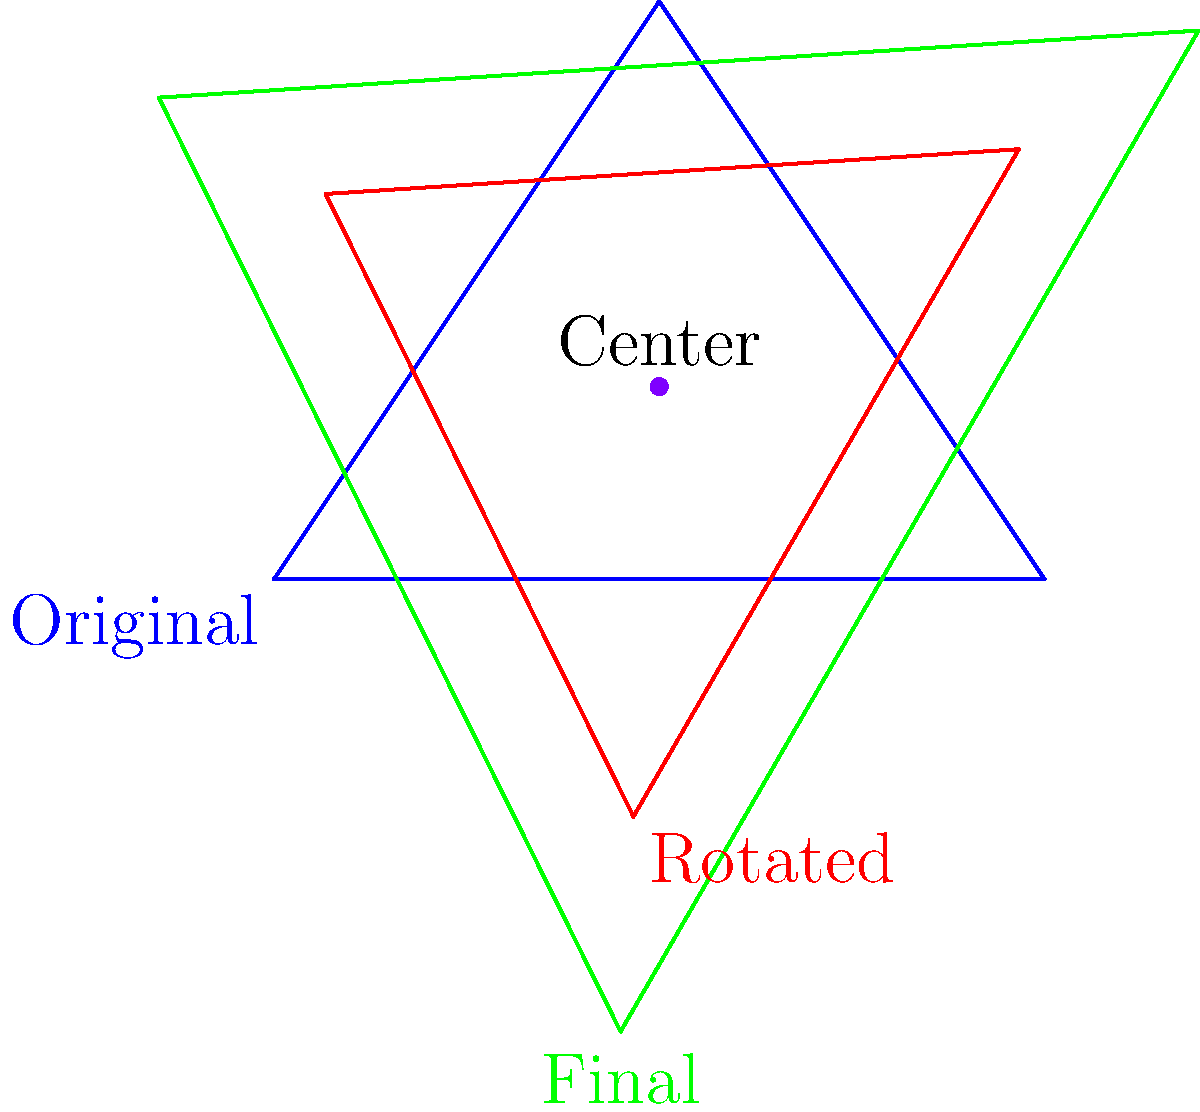In a legislative body, a triangular shape represents the balance of power between three political factions. The shape undergoes two transformations: first, a rotation of 60° clockwise around the point (2,1), and then a scaling by a factor of 1.5 from the same center. What is the composite transformation that describes this sequence of changes? To find the composite transformation, we need to combine the rotation and scaling operations:

1. First transformation: Rotation
   - Angle: 60° clockwise (or -60° counterclockwise)
   - Center: (2,1)
   - Rotation matrix: $R_{-60°} = \begin{pmatrix} \cos(-60°) & -\sin(-60°) \\ \sin(-60°) & \cos(-60°) \end{pmatrix}$

2. Second transformation: Scaling
   - Scale factor: 1.5
   - Center: (2,1)
   - Scaling matrix: $S_{1.5} = \begin{pmatrix} 1.5 & 0 \\ 0 & 1.5 \end{pmatrix}$

3. Composite transformation:
   - Order: Scaling after rotation
   - Composite matrix: $C = S_{1.5} \cdot R_{-60°}$

4. Final composite transformation:
   $C = \begin{pmatrix} 1.5 & 0 \\ 0 & 1.5 \end{pmatrix} \cdot \begin{pmatrix} \cos(-60°) & -\sin(-60°) \\ \sin(-60°) & \cos(-60°) \end{pmatrix}$

   $C = \begin{pmatrix} 1.5\cos(-60°) & -1.5\sin(-60°) \\ 1.5\sin(-60°) & 1.5\cos(-60°) \end{pmatrix}$

5. The composite transformation is a rotation by -60° followed by a scaling of 1.5, both with respect to the center (2,1).
Answer: Rotation by -60° followed by scaling of 1.5, center (2,1) 